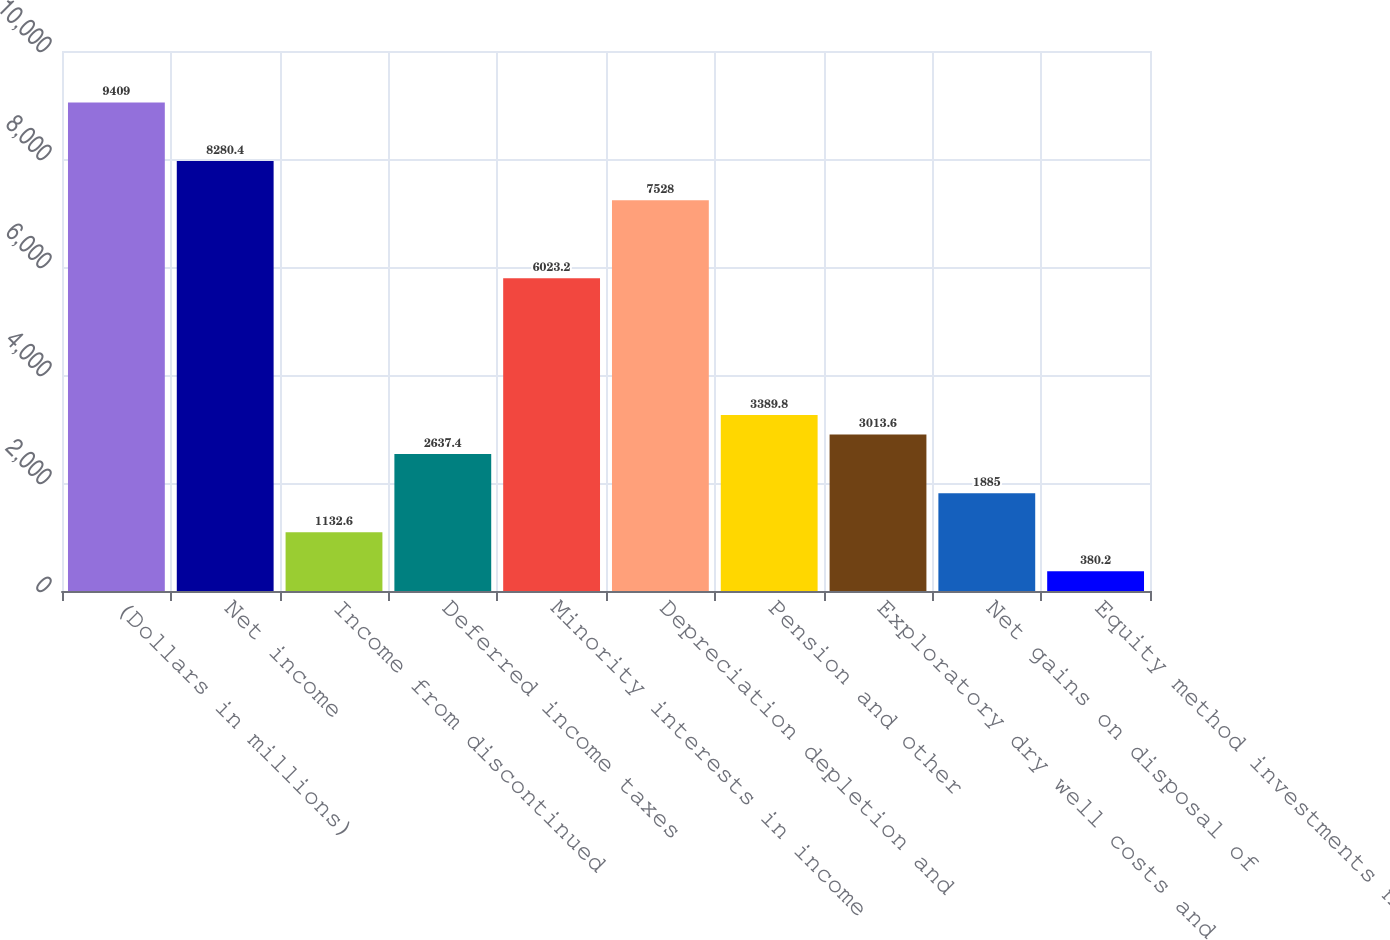Convert chart. <chart><loc_0><loc_0><loc_500><loc_500><bar_chart><fcel>(Dollars in millions)<fcel>Net income<fcel>Income from discontinued<fcel>Deferred income taxes<fcel>Minority interests in income<fcel>Depreciation depletion and<fcel>Pension and other<fcel>Exploratory dry well costs and<fcel>Net gains on disposal of<fcel>Equity method investments net<nl><fcel>9409<fcel>8280.4<fcel>1132.6<fcel>2637.4<fcel>6023.2<fcel>7528<fcel>3389.8<fcel>3013.6<fcel>1885<fcel>380.2<nl></chart> 